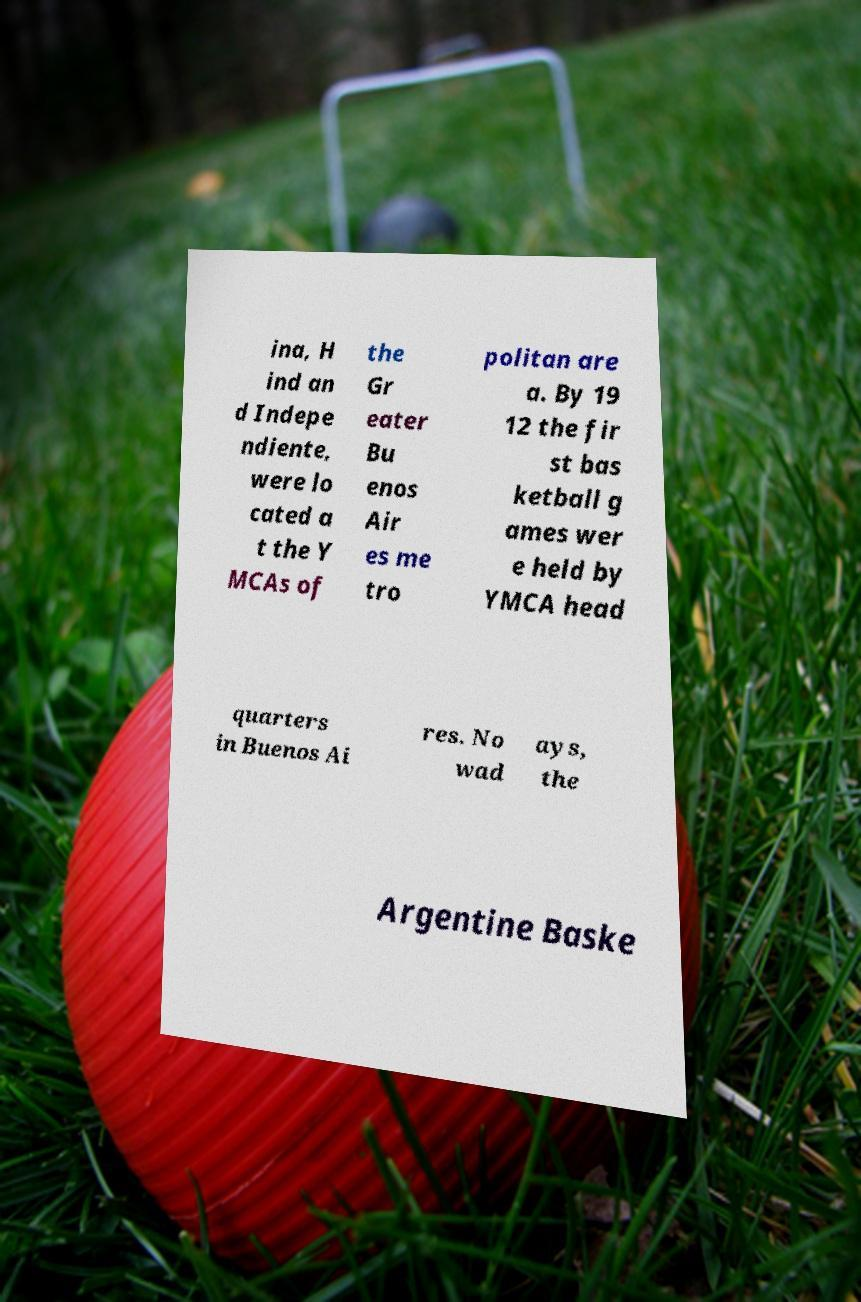There's text embedded in this image that I need extracted. Can you transcribe it verbatim? ina, H ind an d Indepe ndiente, were lo cated a t the Y MCAs of the Gr eater Bu enos Air es me tro politan are a. By 19 12 the fir st bas ketball g ames wer e held by YMCA head quarters in Buenos Ai res. No wad ays, the Argentine Baske 